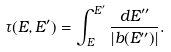<formula> <loc_0><loc_0><loc_500><loc_500>\tau ( E , E ^ { \prime } ) = \int _ { E } ^ { E ^ { \prime } } { \frac { d E ^ { \prime \prime } } { \left | b ( E ^ { \prime \prime } ) \right | } } .</formula> 